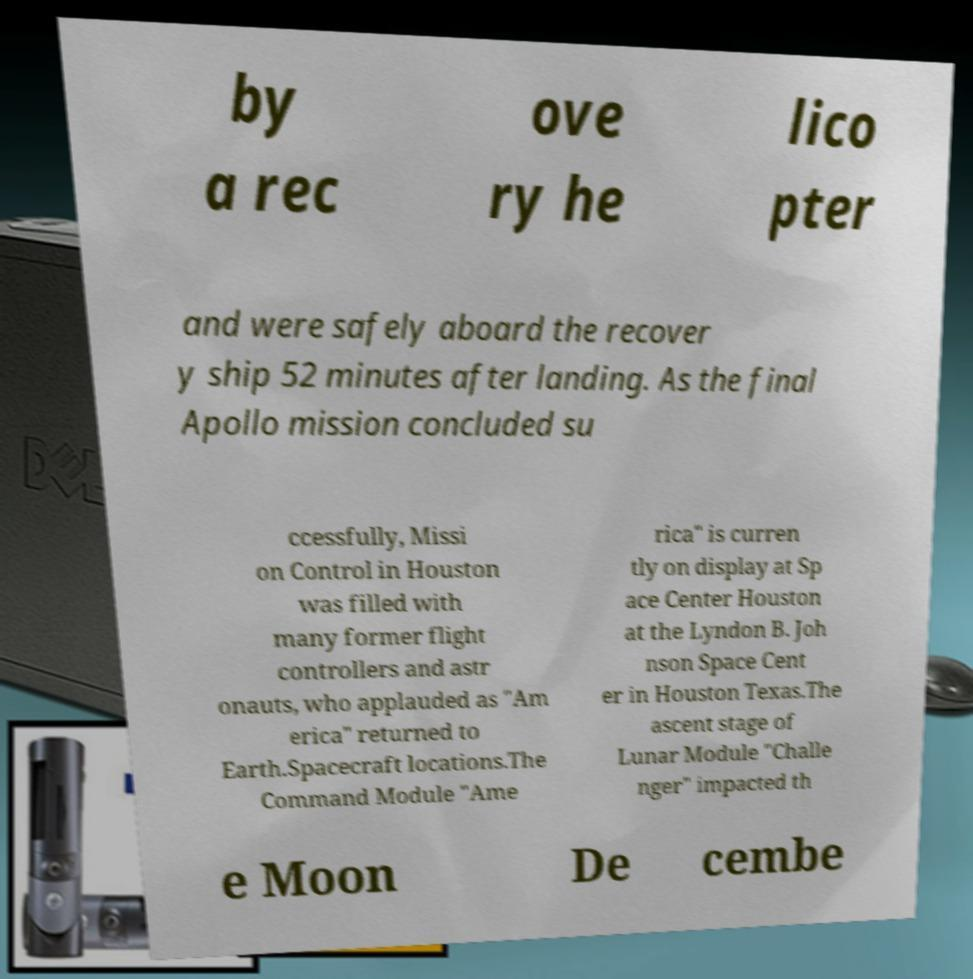Could you extract and type out the text from this image? by a rec ove ry he lico pter and were safely aboard the recover y ship 52 minutes after landing. As the final Apollo mission concluded su ccessfully, Missi on Control in Houston was filled with many former flight controllers and astr onauts, who applauded as "Am erica" returned to Earth.Spacecraft locations.The Command Module "Ame rica" is curren tly on display at Sp ace Center Houston at the Lyndon B. Joh nson Space Cent er in Houston Texas.The ascent stage of Lunar Module "Challe nger" impacted th e Moon De cembe 